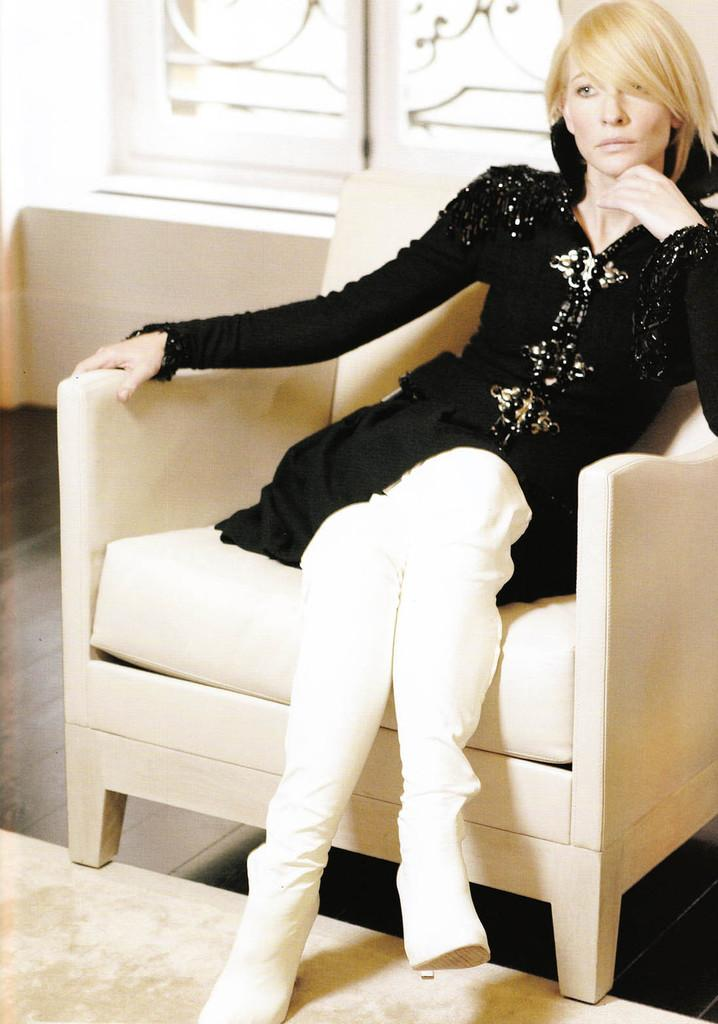Who is the main subject in the image? There is a lady in the image. What is the lady wearing on her upper body? The lady is wearing a black top. What is the lady wearing on her lower body? The lady is wearing white pants. Where is the lady sitting in the image? The lady is sitting on a sofa. How many spiders are crawling on the lady's black top in the image? There are no spiders visible on the lady's black top in the image. What type of crib is present in the image? There is no crib present in the image. 